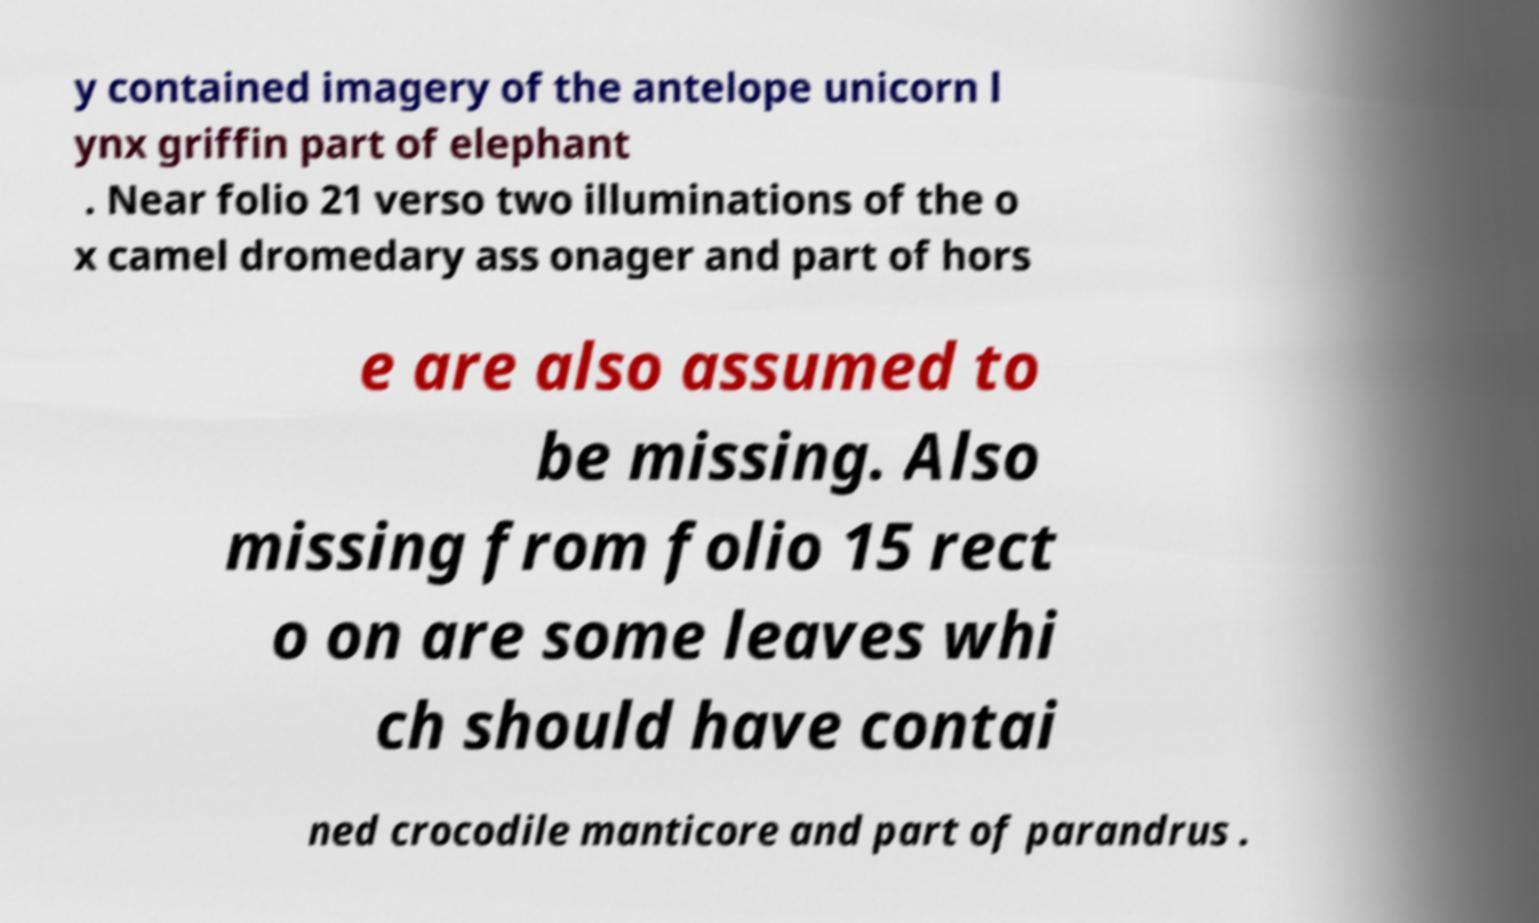Please identify and transcribe the text found in this image. y contained imagery of the antelope unicorn l ynx griffin part of elephant . Near folio 21 verso two illuminations of the o x camel dromedary ass onager and part of hors e are also assumed to be missing. Also missing from folio 15 rect o on are some leaves whi ch should have contai ned crocodile manticore and part of parandrus . 